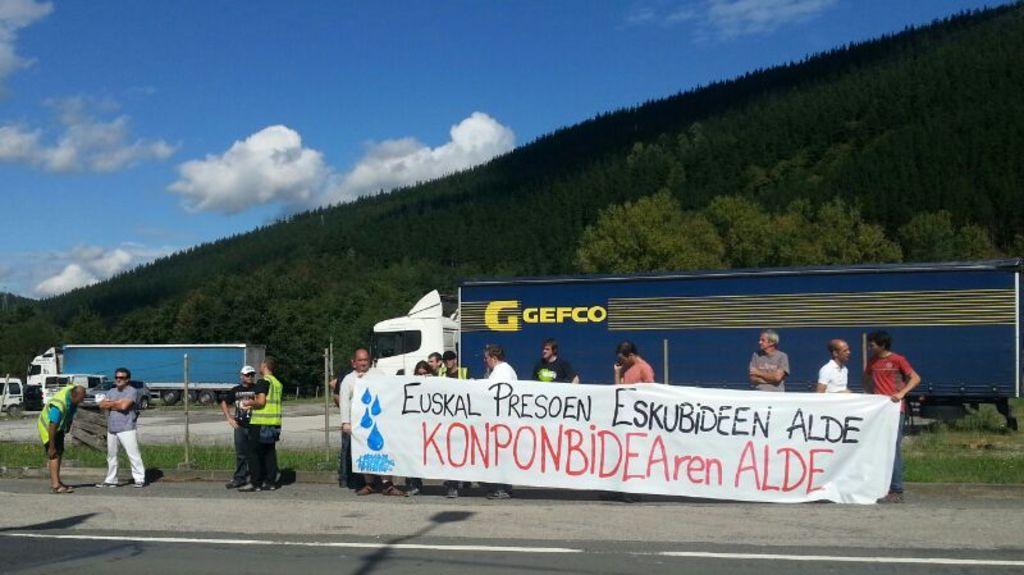Can you describe this image briefly? At the bottom of the image I can see the road. Beside the road I can see few people are standing by holding a white color banner in the hands. On the banner I can see some text. At the back of these people I can see few vehicles on the ground. In the background there are some trees and a hill. At the top I can see the sky and clouds. 